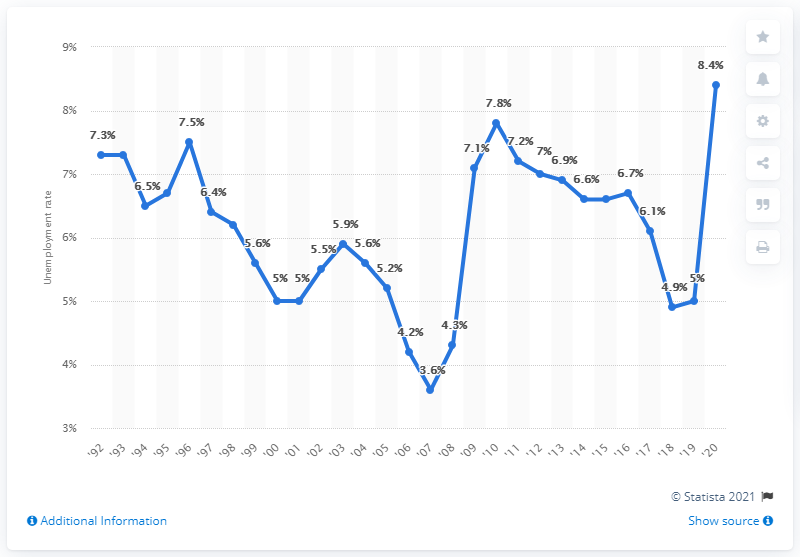Identify some key points in this picture. In 2020, the unemployment rate in New Mexico was 8.4%. The previous unemployment rate in New Mexico was 8.4%. 